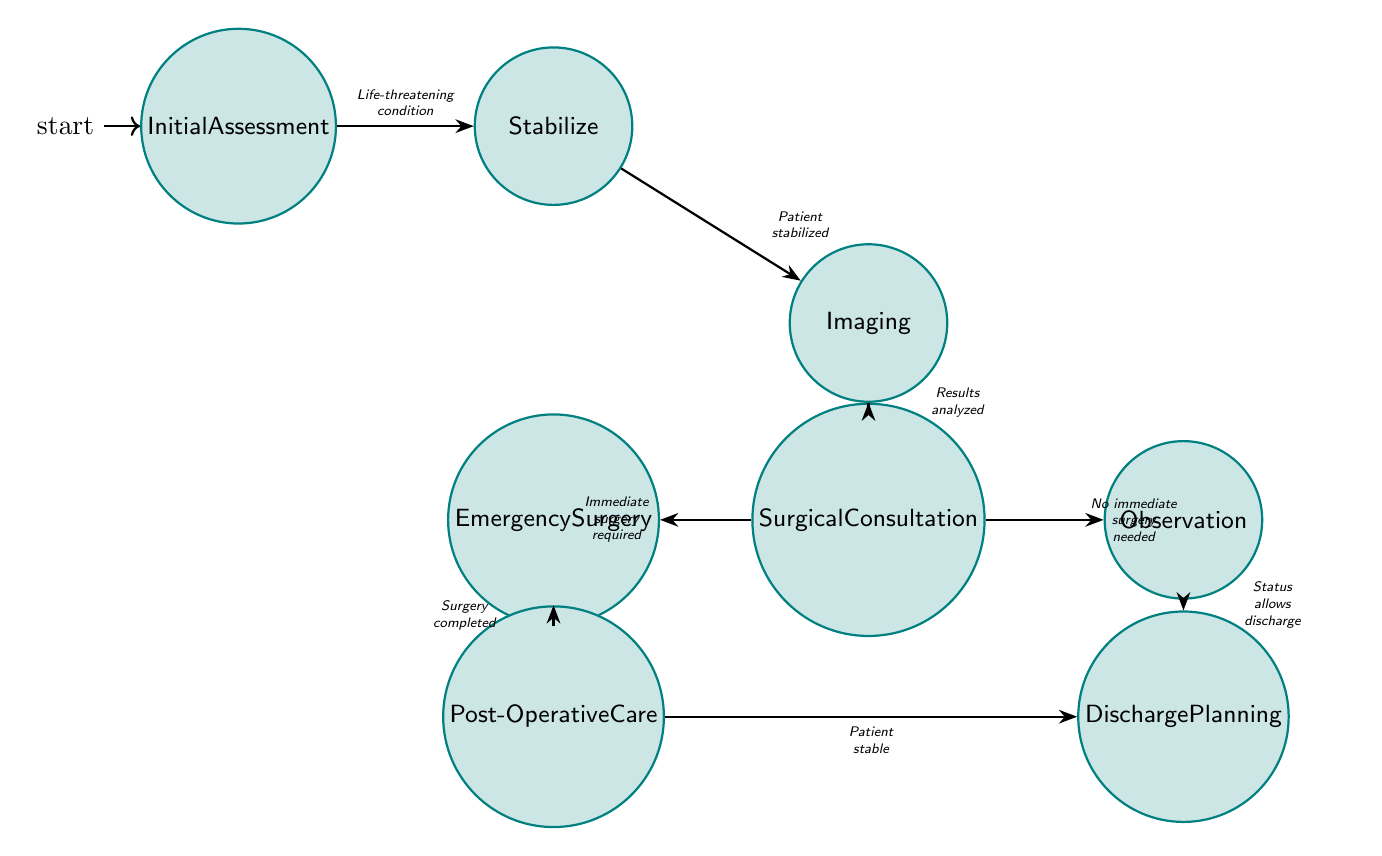What is the starting state of the diagram? The diagram begins with the state "InitialAssessment," which is the first node displayed in the flow of surgical decision-making.
Answer: InitialAssessment How many states are there in the diagram? By counting the nodes shown in the diagram, there are a total of eight states: InitialAssessment, Stabilize, Imaging, SurgicalConsultation, EmergencySurgery, Observation, PostOperativeCare, and DischargePlanning.
Answer: 8 What condition leads from "InitialAssessment" to "Stabilize"? The transition from "InitialAssessment" to "Stabilize" occurs if there is a life-threatening condition that requires stabilization of the patient, as indicated by the label on the connecting edge.
Answer: Life-threatening condition Which state follows "EmergencySurgery"? After the state "EmergencySurgery," the next state to follow in the diagram is "PostOperativeCare," indicating the next step in the surgical process after emergency surgery is completed.
Answer: PostOperativeCare How many transitions are there in total? The diagram shows a total of seven transitions connecting various states in the surgical decision-making process, which can be counted from the edges depicted between nodes.
Answer: 7 If a patient is stabilized, what is the next state? Once the patient is stabilized, as indicated in the diagram, the next state they will transition to is "Imaging," where imaging studies will be conducted to assess internal injuries.
Answer: Imaging What is the condition that leads from "SurgicalConsultation" to "Observation"? If the surgical team determines that no immediate surgery is required after examining the patient's condition, the transition will lead from "SurgicalConsultation" to "Observation."
Answer: No immediate surgery needed What occurs after "PostOperativeCare"? Following the completion of "PostOperativeCare," if the patient is stable, the next state will be "DischargePlanning," which prepares for the patient's discharge or transfer.
Answer: DischargePlanning Which state is connected to "Imaging" with the condition of analyzing results? The state connected to "Imaging" with the transition labeled as "Results analyzed" is "SurgicalConsultation," indicating a critical step of consulting the surgical team based on the imaging obtained.
Answer: SurgicalConsultation 